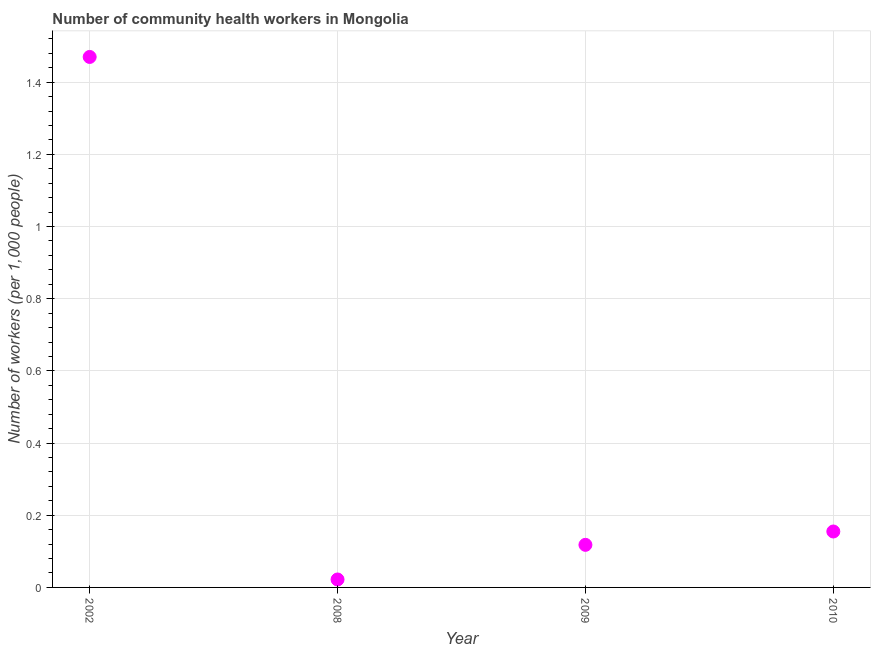What is the number of community health workers in 2008?
Offer a terse response. 0.02. Across all years, what is the maximum number of community health workers?
Your answer should be compact. 1.47. Across all years, what is the minimum number of community health workers?
Make the answer very short. 0.02. What is the sum of the number of community health workers?
Keep it short and to the point. 1.76. What is the difference between the number of community health workers in 2002 and 2009?
Provide a succinct answer. 1.35. What is the average number of community health workers per year?
Provide a short and direct response. 0.44. What is the median number of community health workers?
Your answer should be very brief. 0.14. In how many years, is the number of community health workers greater than 1.4800000000000002 ?
Your answer should be very brief. 0. Do a majority of the years between 2010 and 2008 (inclusive) have number of community health workers greater than 0.12 ?
Make the answer very short. No. What is the ratio of the number of community health workers in 2009 to that in 2010?
Your answer should be very brief. 0.76. Is the difference between the number of community health workers in 2008 and 2010 greater than the difference between any two years?
Keep it short and to the point. No. What is the difference between the highest and the second highest number of community health workers?
Your answer should be compact. 1.31. Is the sum of the number of community health workers in 2002 and 2009 greater than the maximum number of community health workers across all years?
Your answer should be compact. Yes. What is the difference between the highest and the lowest number of community health workers?
Provide a short and direct response. 1.45. In how many years, is the number of community health workers greater than the average number of community health workers taken over all years?
Provide a short and direct response. 1. Does the number of community health workers monotonically increase over the years?
Keep it short and to the point. No. How many years are there in the graph?
Make the answer very short. 4. What is the difference between two consecutive major ticks on the Y-axis?
Your response must be concise. 0.2. Are the values on the major ticks of Y-axis written in scientific E-notation?
Give a very brief answer. No. What is the title of the graph?
Offer a very short reply. Number of community health workers in Mongolia. What is the label or title of the X-axis?
Offer a terse response. Year. What is the label or title of the Y-axis?
Provide a succinct answer. Number of workers (per 1,0 people). What is the Number of workers (per 1,000 people) in 2002?
Your response must be concise. 1.47. What is the Number of workers (per 1,000 people) in 2008?
Provide a succinct answer. 0.02. What is the Number of workers (per 1,000 people) in 2009?
Your response must be concise. 0.12. What is the Number of workers (per 1,000 people) in 2010?
Offer a terse response. 0.15. What is the difference between the Number of workers (per 1,000 people) in 2002 and 2008?
Make the answer very short. 1.45. What is the difference between the Number of workers (per 1,000 people) in 2002 and 2009?
Offer a very short reply. 1.35. What is the difference between the Number of workers (per 1,000 people) in 2002 and 2010?
Keep it short and to the point. 1.31. What is the difference between the Number of workers (per 1,000 people) in 2008 and 2009?
Your answer should be very brief. -0.1. What is the difference between the Number of workers (per 1,000 people) in 2008 and 2010?
Your answer should be compact. -0.13. What is the difference between the Number of workers (per 1,000 people) in 2009 and 2010?
Offer a terse response. -0.04. What is the ratio of the Number of workers (per 1,000 people) in 2002 to that in 2008?
Ensure brevity in your answer.  66.82. What is the ratio of the Number of workers (per 1,000 people) in 2002 to that in 2009?
Your answer should be very brief. 12.46. What is the ratio of the Number of workers (per 1,000 people) in 2002 to that in 2010?
Offer a very short reply. 9.48. What is the ratio of the Number of workers (per 1,000 people) in 2008 to that in 2009?
Your answer should be very brief. 0.19. What is the ratio of the Number of workers (per 1,000 people) in 2008 to that in 2010?
Make the answer very short. 0.14. What is the ratio of the Number of workers (per 1,000 people) in 2009 to that in 2010?
Your response must be concise. 0.76. 